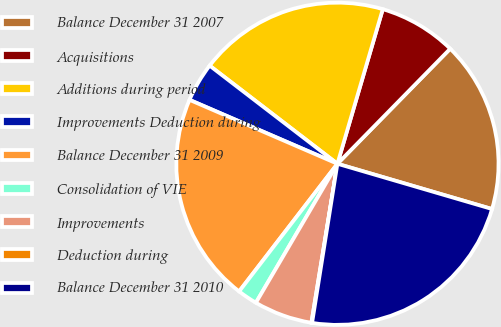Convert chart. <chart><loc_0><loc_0><loc_500><loc_500><pie_chart><fcel>Balance December 31 2007<fcel>Acquisitions<fcel>Additions during period<fcel>Improvements Deduction during<fcel>Balance December 31 2009<fcel>Consolidation of VIE<fcel>Improvements<fcel>Deduction during<fcel>Balance December 31 2010<nl><fcel>17.19%<fcel>7.8%<fcel>19.12%<fcel>3.93%<fcel>21.05%<fcel>2.0%<fcel>5.86%<fcel>0.07%<fcel>22.98%<nl></chart> 